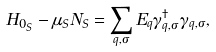<formula> <loc_0><loc_0><loc_500><loc_500>H _ { 0 _ { S } } - \mu _ { S } N _ { S } = \sum _ { q , \sigma } { E _ { q } \gamma ^ { \dagger } _ { q , \sigma } \gamma _ { q , \sigma } } ,</formula> 